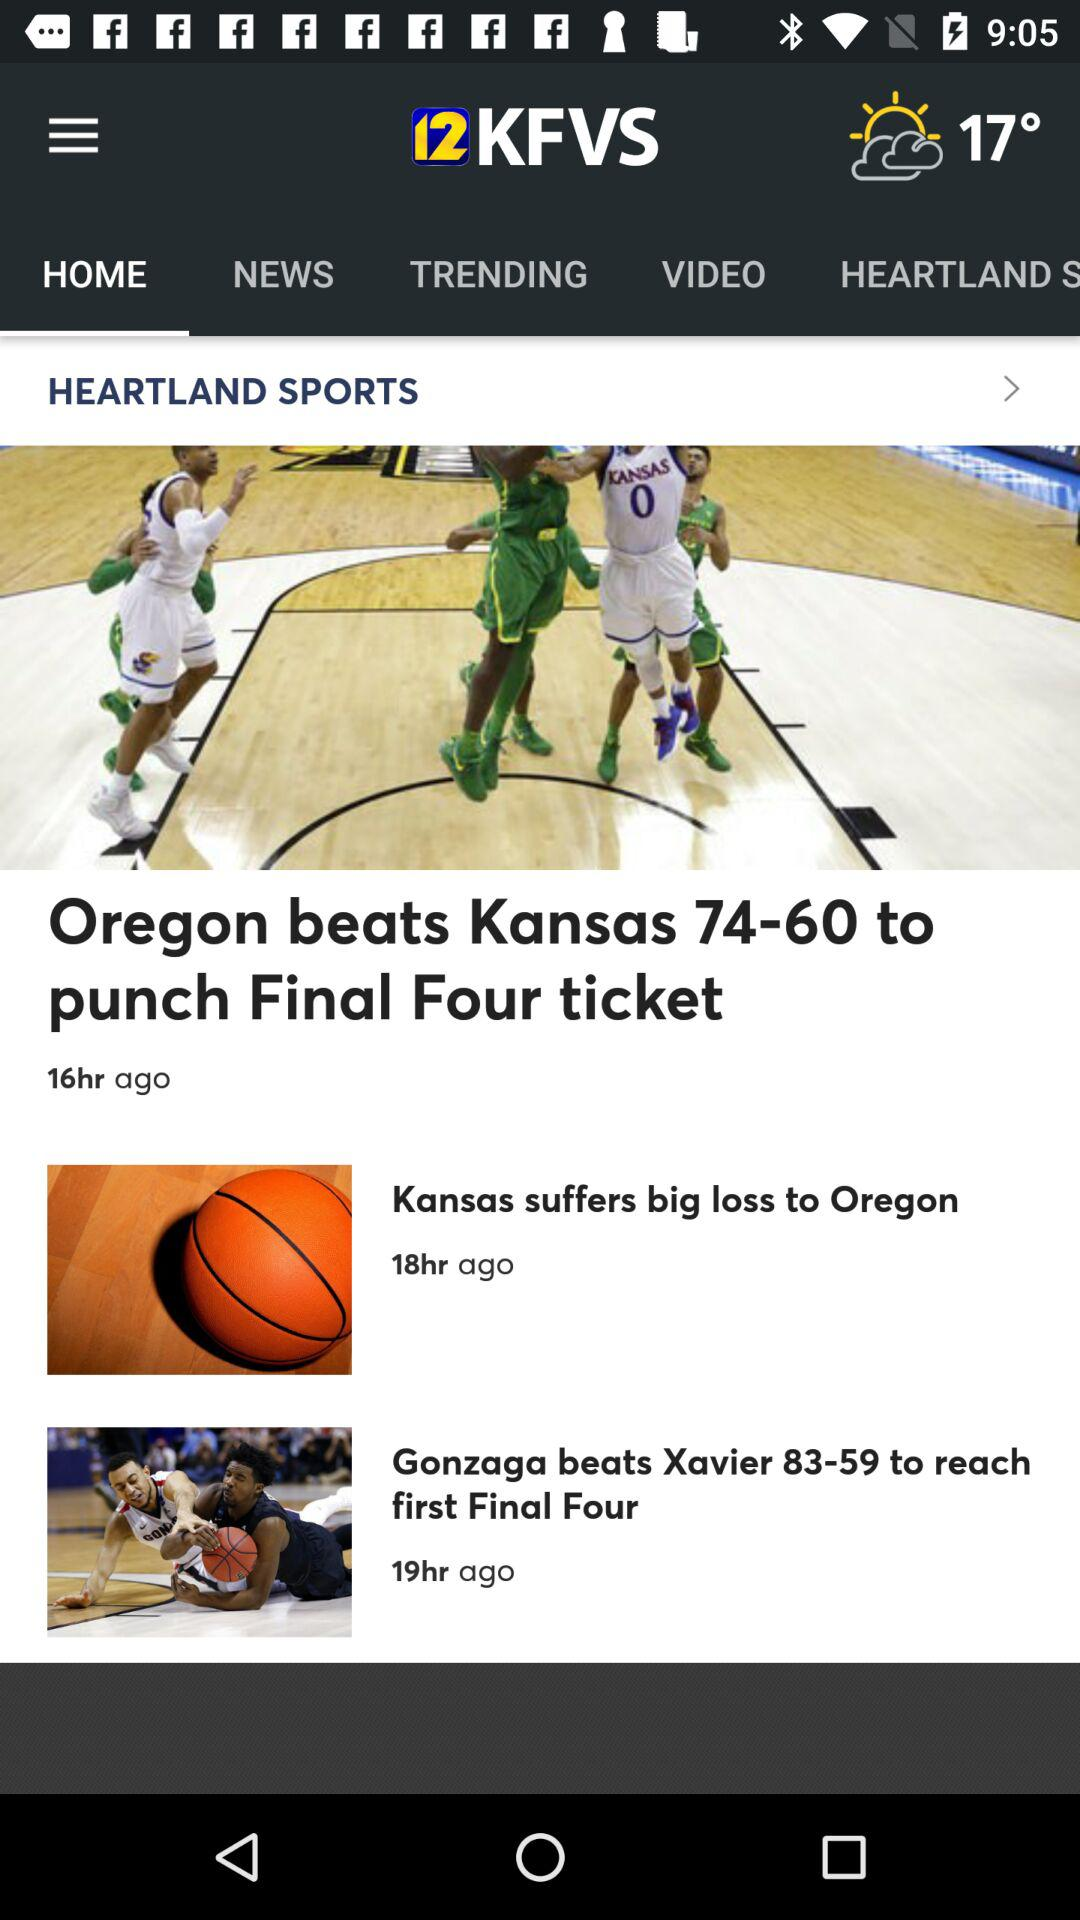When was the news "Kansas suffers big loss to Oregon" posted? The news "Kansas suffers big loss to Oregon" was posted 18 hours ago. 